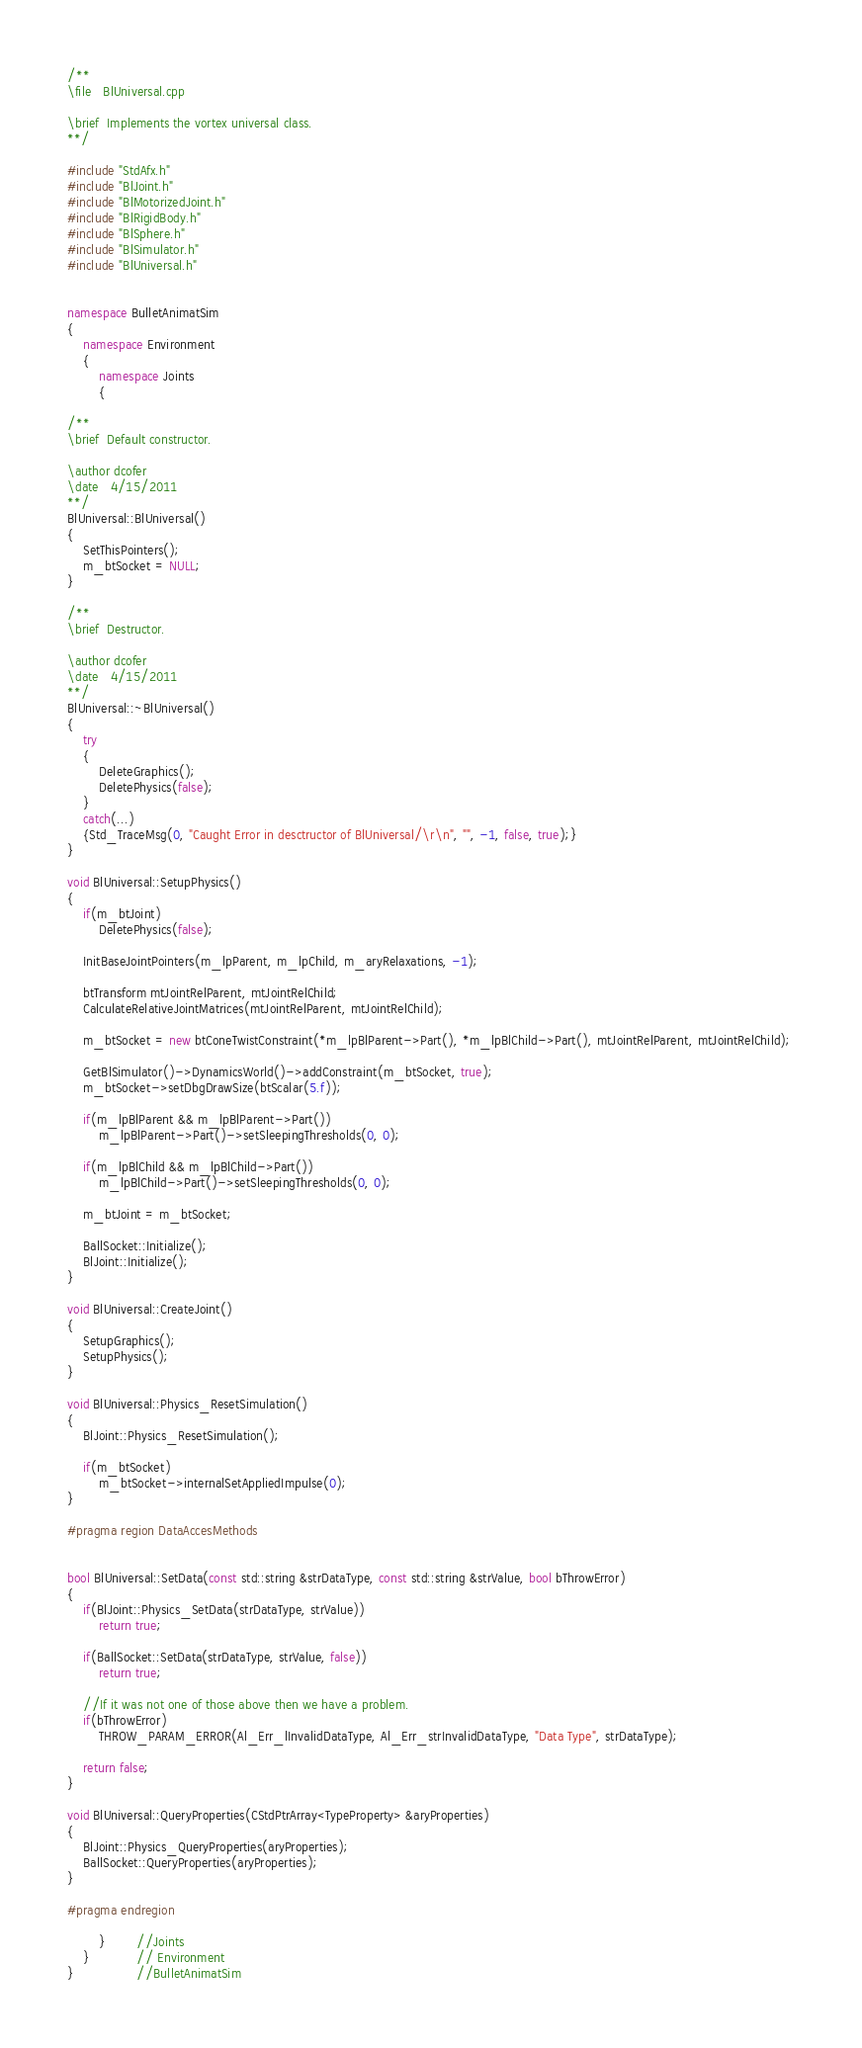Convert code to text. <code><loc_0><loc_0><loc_500><loc_500><_C++_>/**
\file	BlUniversal.cpp

\brief	Implements the vortex universal class.
**/

#include "StdAfx.h"
#include "BlJoint.h"
#include "BlMotorizedJoint.h"
#include "BlRigidBody.h"
#include "BlSphere.h"
#include "BlSimulator.h"
#include "BlUniversal.h"


namespace BulletAnimatSim
{
	namespace Environment
	{
		namespace Joints
		{

/**
\brief	Default constructor.

\author	dcofer
\date	4/15/2011
**/
BlUniversal::BlUniversal()
{
	SetThisPointers();
 	m_btSocket = NULL;
}

/**
\brief	Destructor.

\author	dcofer
\date	4/15/2011
**/
BlUniversal::~BlUniversal()
{
	try
	{
		DeleteGraphics();
		DeletePhysics(false);
	}
	catch(...)
	{Std_TraceMsg(0, "Caught Error in desctructor of BlUniversal/\r\n", "", -1, false, true);}
}

void BlUniversal::SetupPhysics()
{
    if(m_btJoint)
		DeletePhysics(false);

    InitBaseJointPointers(m_lpParent, m_lpChild, m_aryRelaxations, -1);

    btTransform mtJointRelParent, mtJointRelChild;
    CalculateRelativeJointMatrices(mtJointRelParent, mtJointRelChild);

	m_btSocket = new btConeTwistConstraint(*m_lpBlParent->Part(), *m_lpBlChild->Part(), mtJointRelParent, mtJointRelChild); 

    GetBlSimulator()->DynamicsWorld()->addConstraint(m_btSocket, true);
    m_btSocket->setDbgDrawSize(btScalar(5.f));

    if(m_lpBlParent && m_lpBlParent->Part())
        m_lpBlParent->Part()->setSleepingThresholds(0, 0);

    if(m_lpBlChild && m_lpBlChild->Part())
        m_lpBlChild->Part()->setSleepingThresholds(0, 0);

	m_btJoint = m_btSocket;

    BallSocket::Initialize();
    BlJoint::Initialize();
}

void BlUniversal::CreateJoint()
{
	SetupGraphics();
	SetupPhysics();
}

void BlUniversal::Physics_ResetSimulation()
{
    BlJoint::Physics_ResetSimulation();

    if(m_btSocket)
        m_btSocket->internalSetAppliedImpulse(0);
}

#pragma region DataAccesMethods


bool BlUniversal::SetData(const std::string &strDataType, const std::string &strValue, bool bThrowError)
{
	if(BlJoint::Physics_SetData(strDataType, strValue))
		return true;

	if(BallSocket::SetData(strDataType, strValue, false))
		return true;

	//If it was not one of those above then we have a problem.
	if(bThrowError)
		THROW_PARAM_ERROR(Al_Err_lInvalidDataType, Al_Err_strInvalidDataType, "Data Type", strDataType);

	return false;
}

void BlUniversal::QueryProperties(CStdPtrArray<TypeProperty> &aryProperties)
{
	BlJoint::Physics_QueryProperties(aryProperties);
	BallSocket::QueryProperties(aryProperties);
}

#pragma endregion

		}		//Joints
	}			// Environment
}				//BulletAnimatSim
</code> 